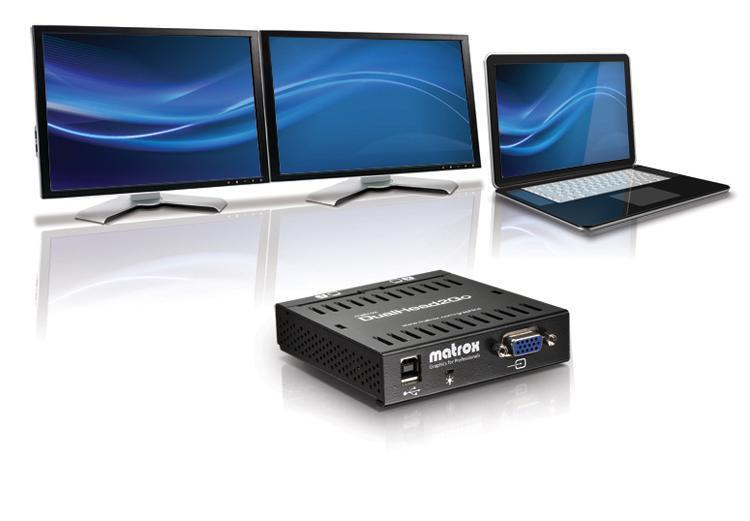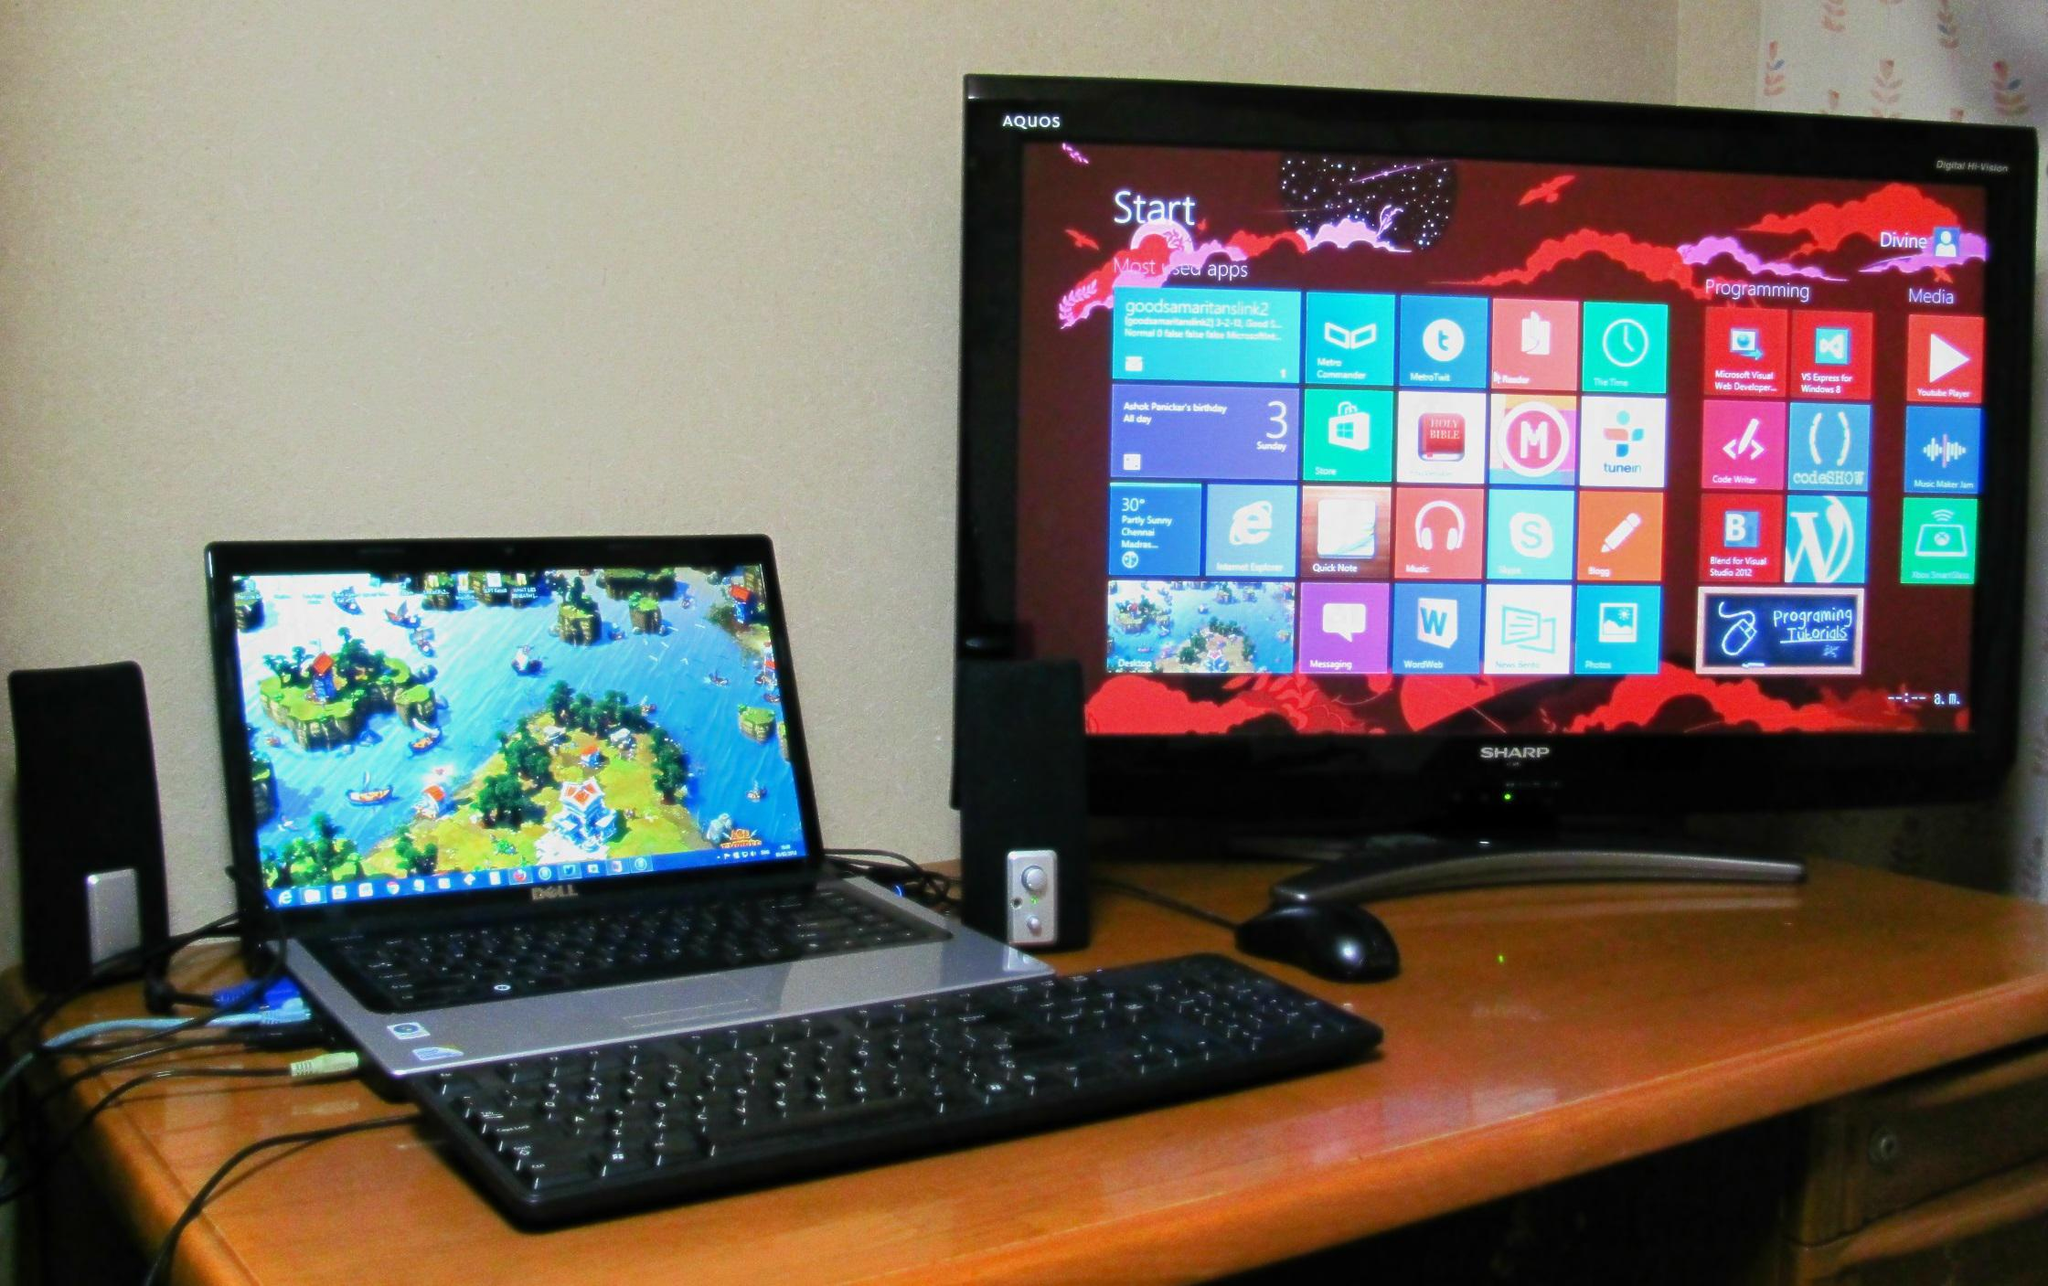The first image is the image on the left, the second image is the image on the right. For the images displayed, is the sentence "Three computer screens are lined up in each picture." factually correct? Answer yes or no. No. The first image is the image on the left, the second image is the image on the right. Given the left and right images, does the statement "The external monitors are showing the same image as the laptop." hold true? Answer yes or no. Yes. 